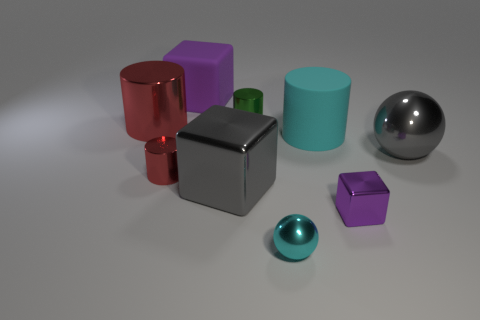Subtract 1 cylinders. How many cylinders are left? 3 Subtract all cyan cubes. Subtract all blue cylinders. How many cubes are left? 3 Subtract all cylinders. How many objects are left? 5 Add 2 small red things. How many small red things exist? 3 Subtract 1 purple blocks. How many objects are left? 8 Subtract all purple matte objects. Subtract all purple matte things. How many objects are left? 7 Add 4 blocks. How many blocks are left? 7 